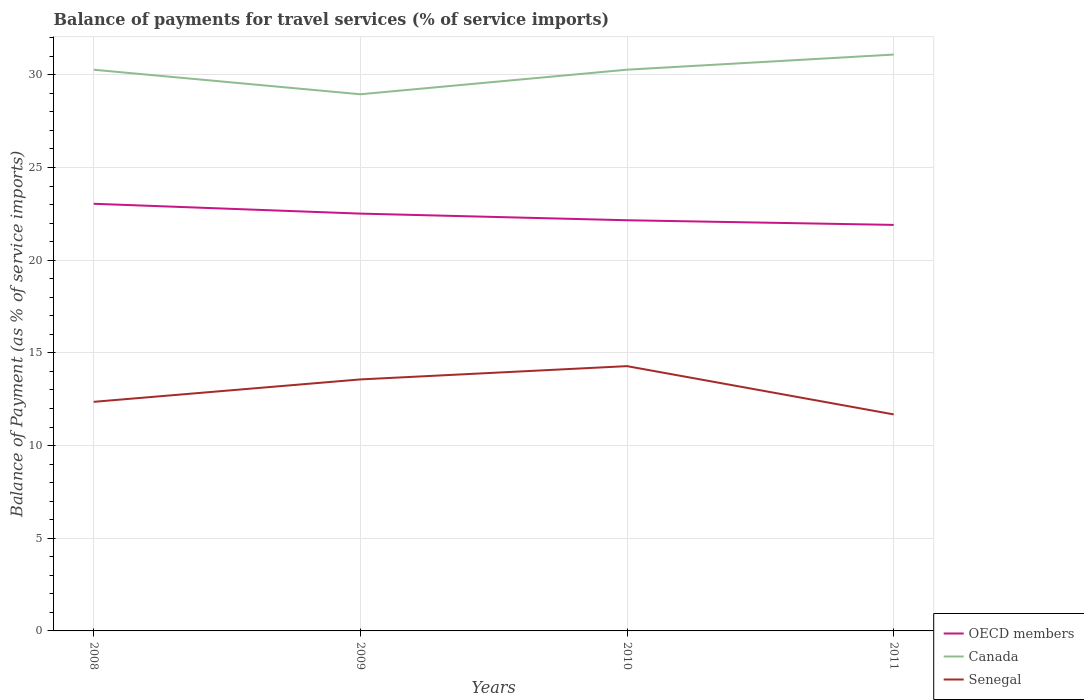How many different coloured lines are there?
Keep it short and to the point. 3. Does the line corresponding to Canada intersect with the line corresponding to Senegal?
Ensure brevity in your answer.  No. Is the number of lines equal to the number of legend labels?
Your answer should be compact. Yes. Across all years, what is the maximum balance of payments for travel services in OECD members?
Provide a succinct answer. 21.9. What is the total balance of payments for travel services in Senegal in the graph?
Your response must be concise. -0.72. What is the difference between the highest and the second highest balance of payments for travel services in OECD members?
Make the answer very short. 1.14. Is the balance of payments for travel services in Senegal strictly greater than the balance of payments for travel services in OECD members over the years?
Provide a short and direct response. Yes. How many years are there in the graph?
Your answer should be compact. 4. How are the legend labels stacked?
Provide a succinct answer. Vertical. What is the title of the graph?
Provide a short and direct response. Balance of payments for travel services (% of service imports). Does "Bahrain" appear as one of the legend labels in the graph?
Give a very brief answer. No. What is the label or title of the X-axis?
Give a very brief answer. Years. What is the label or title of the Y-axis?
Your response must be concise. Balance of Payment (as % of service imports). What is the Balance of Payment (as % of service imports) in OECD members in 2008?
Offer a very short reply. 23.04. What is the Balance of Payment (as % of service imports) in Canada in 2008?
Your response must be concise. 30.27. What is the Balance of Payment (as % of service imports) of Senegal in 2008?
Make the answer very short. 12.36. What is the Balance of Payment (as % of service imports) of OECD members in 2009?
Make the answer very short. 22.51. What is the Balance of Payment (as % of service imports) of Canada in 2009?
Your answer should be compact. 28.95. What is the Balance of Payment (as % of service imports) in Senegal in 2009?
Your response must be concise. 13.57. What is the Balance of Payment (as % of service imports) of OECD members in 2010?
Make the answer very short. 22.15. What is the Balance of Payment (as % of service imports) in Canada in 2010?
Make the answer very short. 30.28. What is the Balance of Payment (as % of service imports) of Senegal in 2010?
Give a very brief answer. 14.28. What is the Balance of Payment (as % of service imports) of OECD members in 2011?
Provide a succinct answer. 21.9. What is the Balance of Payment (as % of service imports) in Canada in 2011?
Your answer should be very brief. 31.09. What is the Balance of Payment (as % of service imports) in Senegal in 2011?
Your response must be concise. 11.68. Across all years, what is the maximum Balance of Payment (as % of service imports) of OECD members?
Provide a short and direct response. 23.04. Across all years, what is the maximum Balance of Payment (as % of service imports) in Canada?
Make the answer very short. 31.09. Across all years, what is the maximum Balance of Payment (as % of service imports) of Senegal?
Keep it short and to the point. 14.28. Across all years, what is the minimum Balance of Payment (as % of service imports) in OECD members?
Provide a short and direct response. 21.9. Across all years, what is the minimum Balance of Payment (as % of service imports) in Canada?
Keep it short and to the point. 28.95. Across all years, what is the minimum Balance of Payment (as % of service imports) in Senegal?
Your response must be concise. 11.68. What is the total Balance of Payment (as % of service imports) of OECD members in the graph?
Offer a very short reply. 89.61. What is the total Balance of Payment (as % of service imports) in Canada in the graph?
Offer a terse response. 120.6. What is the total Balance of Payment (as % of service imports) of Senegal in the graph?
Ensure brevity in your answer.  51.89. What is the difference between the Balance of Payment (as % of service imports) of OECD members in 2008 and that in 2009?
Provide a short and direct response. 0.53. What is the difference between the Balance of Payment (as % of service imports) of Canada in 2008 and that in 2009?
Your response must be concise. 1.32. What is the difference between the Balance of Payment (as % of service imports) in Senegal in 2008 and that in 2009?
Ensure brevity in your answer.  -1.21. What is the difference between the Balance of Payment (as % of service imports) of OECD members in 2008 and that in 2010?
Provide a succinct answer. 0.89. What is the difference between the Balance of Payment (as % of service imports) in Canada in 2008 and that in 2010?
Ensure brevity in your answer.  -0. What is the difference between the Balance of Payment (as % of service imports) in Senegal in 2008 and that in 2010?
Offer a terse response. -1.93. What is the difference between the Balance of Payment (as % of service imports) of OECD members in 2008 and that in 2011?
Offer a very short reply. 1.14. What is the difference between the Balance of Payment (as % of service imports) of Canada in 2008 and that in 2011?
Ensure brevity in your answer.  -0.82. What is the difference between the Balance of Payment (as % of service imports) in Senegal in 2008 and that in 2011?
Offer a terse response. 0.68. What is the difference between the Balance of Payment (as % of service imports) in OECD members in 2009 and that in 2010?
Keep it short and to the point. 0.36. What is the difference between the Balance of Payment (as % of service imports) of Canada in 2009 and that in 2010?
Offer a very short reply. -1.33. What is the difference between the Balance of Payment (as % of service imports) of Senegal in 2009 and that in 2010?
Provide a succinct answer. -0.72. What is the difference between the Balance of Payment (as % of service imports) of OECD members in 2009 and that in 2011?
Ensure brevity in your answer.  0.61. What is the difference between the Balance of Payment (as % of service imports) of Canada in 2009 and that in 2011?
Offer a terse response. -2.14. What is the difference between the Balance of Payment (as % of service imports) in Senegal in 2009 and that in 2011?
Offer a terse response. 1.89. What is the difference between the Balance of Payment (as % of service imports) in OECD members in 2010 and that in 2011?
Your answer should be very brief. 0.25. What is the difference between the Balance of Payment (as % of service imports) in Canada in 2010 and that in 2011?
Your response must be concise. -0.82. What is the difference between the Balance of Payment (as % of service imports) of Senegal in 2010 and that in 2011?
Give a very brief answer. 2.6. What is the difference between the Balance of Payment (as % of service imports) of OECD members in 2008 and the Balance of Payment (as % of service imports) of Canada in 2009?
Your answer should be compact. -5.91. What is the difference between the Balance of Payment (as % of service imports) in OECD members in 2008 and the Balance of Payment (as % of service imports) in Senegal in 2009?
Provide a short and direct response. 9.48. What is the difference between the Balance of Payment (as % of service imports) in Canada in 2008 and the Balance of Payment (as % of service imports) in Senegal in 2009?
Make the answer very short. 16.71. What is the difference between the Balance of Payment (as % of service imports) of OECD members in 2008 and the Balance of Payment (as % of service imports) of Canada in 2010?
Your answer should be compact. -7.23. What is the difference between the Balance of Payment (as % of service imports) of OECD members in 2008 and the Balance of Payment (as % of service imports) of Senegal in 2010?
Make the answer very short. 8.76. What is the difference between the Balance of Payment (as % of service imports) in Canada in 2008 and the Balance of Payment (as % of service imports) in Senegal in 2010?
Offer a terse response. 15.99. What is the difference between the Balance of Payment (as % of service imports) of OECD members in 2008 and the Balance of Payment (as % of service imports) of Canada in 2011?
Provide a short and direct response. -8.05. What is the difference between the Balance of Payment (as % of service imports) in OECD members in 2008 and the Balance of Payment (as % of service imports) in Senegal in 2011?
Offer a very short reply. 11.36. What is the difference between the Balance of Payment (as % of service imports) in Canada in 2008 and the Balance of Payment (as % of service imports) in Senegal in 2011?
Provide a succinct answer. 18.59. What is the difference between the Balance of Payment (as % of service imports) in OECD members in 2009 and the Balance of Payment (as % of service imports) in Canada in 2010?
Your answer should be compact. -7.76. What is the difference between the Balance of Payment (as % of service imports) of OECD members in 2009 and the Balance of Payment (as % of service imports) of Senegal in 2010?
Make the answer very short. 8.23. What is the difference between the Balance of Payment (as % of service imports) of Canada in 2009 and the Balance of Payment (as % of service imports) of Senegal in 2010?
Keep it short and to the point. 14.67. What is the difference between the Balance of Payment (as % of service imports) in OECD members in 2009 and the Balance of Payment (as % of service imports) in Canada in 2011?
Give a very brief answer. -8.58. What is the difference between the Balance of Payment (as % of service imports) of OECD members in 2009 and the Balance of Payment (as % of service imports) of Senegal in 2011?
Your answer should be very brief. 10.83. What is the difference between the Balance of Payment (as % of service imports) in Canada in 2009 and the Balance of Payment (as % of service imports) in Senegal in 2011?
Provide a succinct answer. 17.27. What is the difference between the Balance of Payment (as % of service imports) in OECD members in 2010 and the Balance of Payment (as % of service imports) in Canada in 2011?
Your answer should be very brief. -8.94. What is the difference between the Balance of Payment (as % of service imports) in OECD members in 2010 and the Balance of Payment (as % of service imports) in Senegal in 2011?
Offer a terse response. 10.47. What is the difference between the Balance of Payment (as % of service imports) in Canada in 2010 and the Balance of Payment (as % of service imports) in Senegal in 2011?
Give a very brief answer. 18.6. What is the average Balance of Payment (as % of service imports) in OECD members per year?
Keep it short and to the point. 22.4. What is the average Balance of Payment (as % of service imports) of Canada per year?
Ensure brevity in your answer.  30.15. What is the average Balance of Payment (as % of service imports) of Senegal per year?
Your answer should be very brief. 12.97. In the year 2008, what is the difference between the Balance of Payment (as % of service imports) in OECD members and Balance of Payment (as % of service imports) in Canada?
Your response must be concise. -7.23. In the year 2008, what is the difference between the Balance of Payment (as % of service imports) in OECD members and Balance of Payment (as % of service imports) in Senegal?
Keep it short and to the point. 10.69. In the year 2008, what is the difference between the Balance of Payment (as % of service imports) of Canada and Balance of Payment (as % of service imports) of Senegal?
Give a very brief answer. 17.92. In the year 2009, what is the difference between the Balance of Payment (as % of service imports) of OECD members and Balance of Payment (as % of service imports) of Canada?
Your answer should be very brief. -6.44. In the year 2009, what is the difference between the Balance of Payment (as % of service imports) of OECD members and Balance of Payment (as % of service imports) of Senegal?
Offer a very short reply. 8.94. In the year 2009, what is the difference between the Balance of Payment (as % of service imports) in Canada and Balance of Payment (as % of service imports) in Senegal?
Provide a short and direct response. 15.38. In the year 2010, what is the difference between the Balance of Payment (as % of service imports) of OECD members and Balance of Payment (as % of service imports) of Canada?
Keep it short and to the point. -8.12. In the year 2010, what is the difference between the Balance of Payment (as % of service imports) in OECD members and Balance of Payment (as % of service imports) in Senegal?
Ensure brevity in your answer.  7.87. In the year 2010, what is the difference between the Balance of Payment (as % of service imports) of Canada and Balance of Payment (as % of service imports) of Senegal?
Ensure brevity in your answer.  15.99. In the year 2011, what is the difference between the Balance of Payment (as % of service imports) in OECD members and Balance of Payment (as % of service imports) in Canada?
Provide a short and direct response. -9.19. In the year 2011, what is the difference between the Balance of Payment (as % of service imports) in OECD members and Balance of Payment (as % of service imports) in Senegal?
Keep it short and to the point. 10.22. In the year 2011, what is the difference between the Balance of Payment (as % of service imports) of Canada and Balance of Payment (as % of service imports) of Senegal?
Offer a terse response. 19.41. What is the ratio of the Balance of Payment (as % of service imports) of OECD members in 2008 to that in 2009?
Offer a very short reply. 1.02. What is the ratio of the Balance of Payment (as % of service imports) in Canada in 2008 to that in 2009?
Make the answer very short. 1.05. What is the ratio of the Balance of Payment (as % of service imports) in Senegal in 2008 to that in 2009?
Ensure brevity in your answer.  0.91. What is the ratio of the Balance of Payment (as % of service imports) in OECD members in 2008 to that in 2010?
Provide a short and direct response. 1.04. What is the ratio of the Balance of Payment (as % of service imports) of Senegal in 2008 to that in 2010?
Make the answer very short. 0.87. What is the ratio of the Balance of Payment (as % of service imports) in OECD members in 2008 to that in 2011?
Offer a terse response. 1.05. What is the ratio of the Balance of Payment (as % of service imports) of Canada in 2008 to that in 2011?
Your response must be concise. 0.97. What is the ratio of the Balance of Payment (as % of service imports) of Senegal in 2008 to that in 2011?
Your answer should be very brief. 1.06. What is the ratio of the Balance of Payment (as % of service imports) of OECD members in 2009 to that in 2010?
Keep it short and to the point. 1.02. What is the ratio of the Balance of Payment (as % of service imports) of Canada in 2009 to that in 2010?
Ensure brevity in your answer.  0.96. What is the ratio of the Balance of Payment (as % of service imports) of Senegal in 2009 to that in 2010?
Make the answer very short. 0.95. What is the ratio of the Balance of Payment (as % of service imports) in OECD members in 2009 to that in 2011?
Keep it short and to the point. 1.03. What is the ratio of the Balance of Payment (as % of service imports) of Canada in 2009 to that in 2011?
Provide a short and direct response. 0.93. What is the ratio of the Balance of Payment (as % of service imports) in Senegal in 2009 to that in 2011?
Offer a very short reply. 1.16. What is the ratio of the Balance of Payment (as % of service imports) in OECD members in 2010 to that in 2011?
Ensure brevity in your answer.  1.01. What is the ratio of the Balance of Payment (as % of service imports) of Canada in 2010 to that in 2011?
Your response must be concise. 0.97. What is the ratio of the Balance of Payment (as % of service imports) of Senegal in 2010 to that in 2011?
Your response must be concise. 1.22. What is the difference between the highest and the second highest Balance of Payment (as % of service imports) in OECD members?
Provide a succinct answer. 0.53. What is the difference between the highest and the second highest Balance of Payment (as % of service imports) of Canada?
Keep it short and to the point. 0.82. What is the difference between the highest and the second highest Balance of Payment (as % of service imports) of Senegal?
Provide a short and direct response. 0.72. What is the difference between the highest and the lowest Balance of Payment (as % of service imports) of OECD members?
Provide a succinct answer. 1.14. What is the difference between the highest and the lowest Balance of Payment (as % of service imports) of Canada?
Offer a terse response. 2.14. What is the difference between the highest and the lowest Balance of Payment (as % of service imports) in Senegal?
Keep it short and to the point. 2.6. 